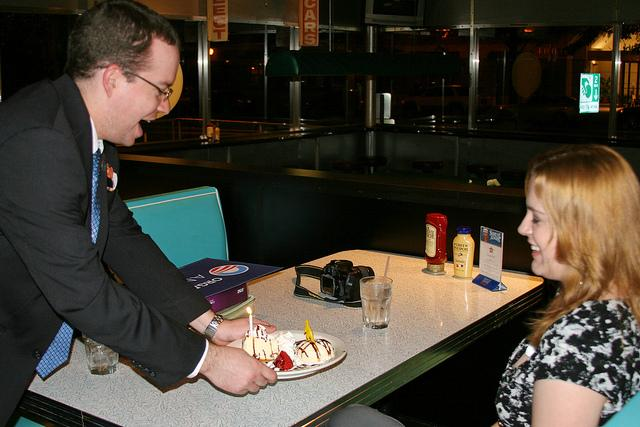Why is there a candle in the woman's dessert? birthday 